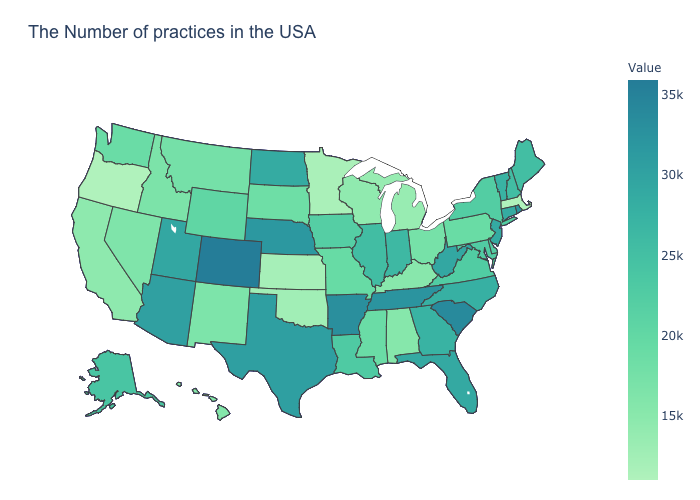Among the states that border Washington , does Oregon have the highest value?
Write a very short answer. No. Is the legend a continuous bar?
Give a very brief answer. Yes. Which states have the highest value in the USA?
Quick response, please. Colorado. Does Oregon have the lowest value in the USA?
Answer briefly. Yes. Which states have the lowest value in the West?
Be succinct. Oregon. 